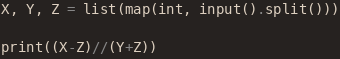Convert code to text. <code><loc_0><loc_0><loc_500><loc_500><_Python_>X, Y, Z = list(map(int, input().split()))

print((X-Z)//(Y+Z))</code> 